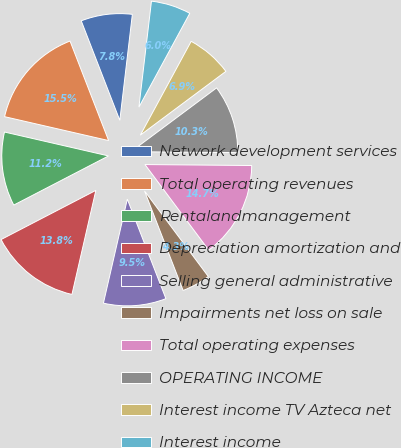Convert chart to OTSL. <chart><loc_0><loc_0><loc_500><loc_500><pie_chart><fcel>Network development services<fcel>Total operating revenues<fcel>Rentalandmanagement<fcel>Depreciation amortization and<fcel>Selling general administrative<fcel>Impairments net loss on sale<fcel>Total operating expenses<fcel>OPERATING INCOME<fcel>Interest income TV Azteca net<fcel>Interest income<nl><fcel>7.76%<fcel>15.52%<fcel>11.21%<fcel>13.79%<fcel>9.48%<fcel>4.31%<fcel>14.66%<fcel>10.34%<fcel>6.9%<fcel>6.03%<nl></chart> 